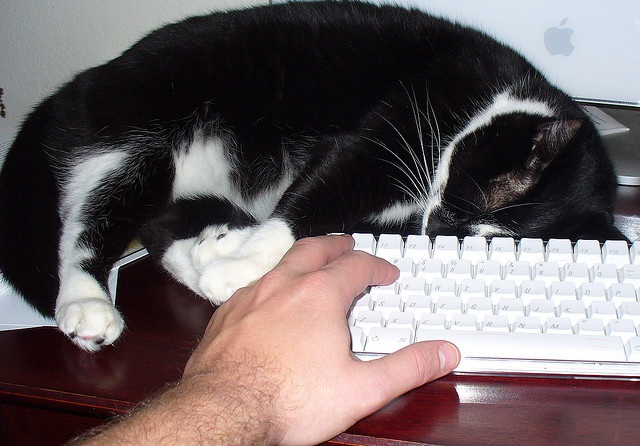Describe the objects in this image and their specific colors. I can see cat in gray, black, lightgray, and darkgray tones, people in gray, lightpink, and pink tones, keyboard in gray, white, darkgray, and black tones, and tv in gray, lightgray, lightblue, darkgray, and black tones in this image. 